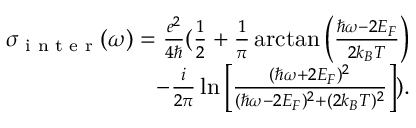Convert formula to latex. <formula><loc_0><loc_0><loc_500><loc_500>\begin{array} { r } { \sigma _ { i n t e r } ( \omega ) = \frac { e ^ { 2 } } { 4 } ( \frac { 1 } { 2 } + \frac { 1 } { \pi } \arctan \left ( \frac { \hbar { \omega } - 2 E _ { F } } { 2 k _ { B } T } \right ) } \\ { - \frac { i } { 2 \pi } \ln \left [ \frac { ( \hbar { \omega } + 2 E _ { F } ) ^ { 2 } } { ( \hbar { \omega } - 2 E _ { F } ) ^ { 2 } + ( 2 k _ { B } T ) ^ { 2 } } \right ] ) . } \end{array}</formula> 